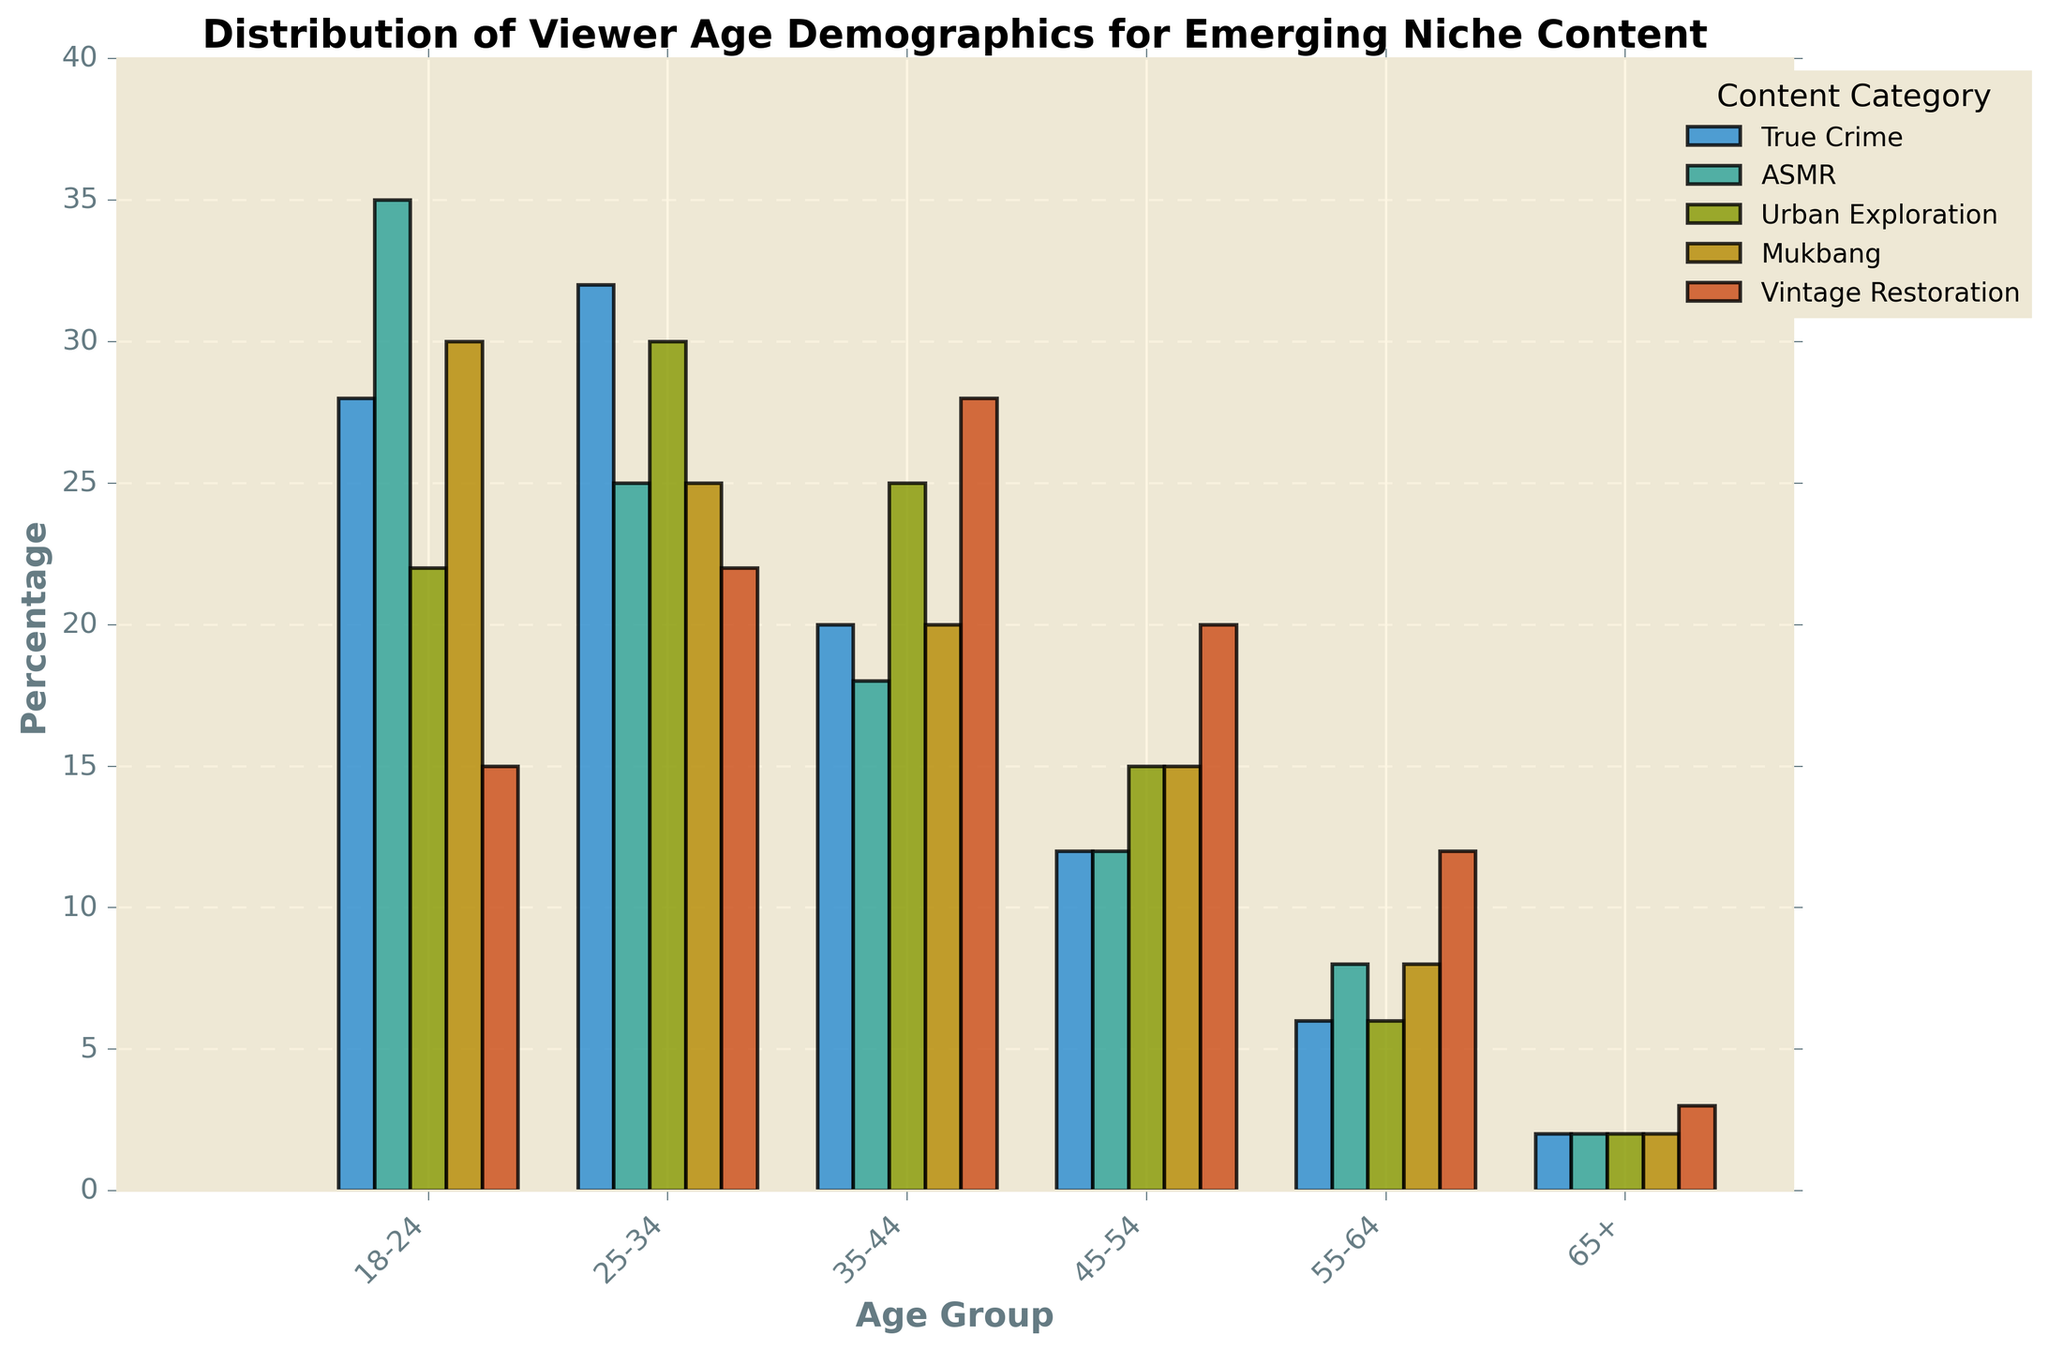What age group has the highest percentage of viewers for ASMR? The bars in the chart for ASMR show that the 18-24 age group has the highest value when compared to other age groups.
Answer: 18-24 Which content category has the lowest percentage of 55-64-year-old viewers? When examining the bars corresponding to the 55-64 age group, True Crime and Urban Exploration both have the lowest value at 6%.
Answer: True Crime and Urban Exploration Compare the percentage of viewers aged 25-34 for True Crime and Mukbang. Which one is higher? The bar for True Crime in the 25-34 age group is higher when compared to the bar for Mukbang. True Crime has 32%, whereas Mukbang has 25%.
Answer: True Crime What is the sum of the percentages for the 35-44 age group across all content categories? Adding the values for 35-44 across all categories: 20 (True Crime) + 18 (ASMR) + 25 (Urban Exploration) + 20 (Mukbang) + 28 (Vintage Restoration) = 111%.
Answer: 111% Which age group has the least uniform distribution across the content categories? By comparing the heights of the bars for each age group, the 18-24 group shows large variations, with percentages ranging from 15% (Vintage Restoration) to 35% (ASMR).
Answer: 18-24 In the 45-54 age group, which content category is more popular: Urban Exploration or Mukbang? By comparing the bars in the 45-54 age group for Urban Exploration and Mukbang, both have the same value of 15%.
Answer: Both Calculate the average percentage of viewers for Vintage Restoration across all age groups. The percentages for Vintage Restoration are 15, 22, 28, 20, 12, and 3. Their sum is 100. The average is 100 divided by 6, which is approximately 16.67%.
Answer: 16.67% What is the difference in percentage between the oldest (65+) and youngest (18-24) viewers for Mukbang? The value for the 65+ age group is 2%, and for the 18-24 age group, it is 30%. The difference is 30% - 2% = 28%.
Answer: 28% Which two content categories have the closest viewer percentage for the 55-64 age group? The values for 55-64 age group are: True Crime (6), ASMR (8), Urban Exploration (6), Mukbang (8), Vintage Restoration (12). True Crime and Urban Exploration both have equal values at 6.
Answer: True Crime and Urban Exploration 